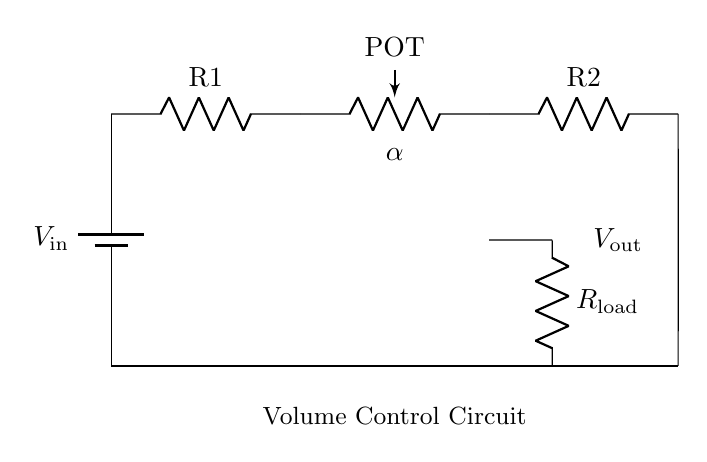What is the input voltage of the circuit? The input voltage is symbolized as V_in at the battery in the circuit.
Answer: V_in What is the role of the potentiometer in this circuit? The potentiometer, labeled as POT, is used to adjust the voltage output, effectively controlling the volume.
Answer: Volume control What component is connected in parallel with the load resistor? The load resistor, R_load, is connected in parallel with the output from the potentiometer to determine the output voltage across it.
Answer: Potentiometer What is the value of the output voltage (V_out) in the circuit? The output voltage V_out is defined across the load resistor R_load, which shows how much voltage is being delivered to the speaker or output device.
Answer: V_out How many resistors are in this circuit? There are two resistors, R1 and R2, in addition to the load resistor R_load and the potentiometer acting as a variable resistor.
Answer: Three What is the effect of adjusting the potentiometer? Adjusting the potentiometer changes its resistance, which in turn alters the voltage drop across it, modifying the volume output.
Answer: Changes output 